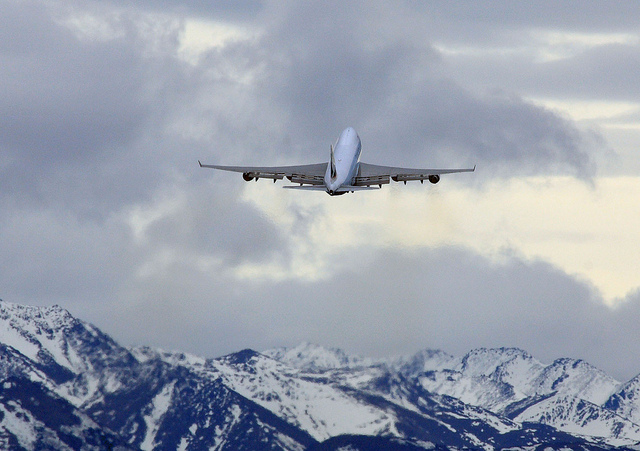What feelings does this image evoke? The image might evoke feelings of awe and freedom due to the vastness of the landscape and the airplane's flight, as well as a sense of wanderlust or a desire for adventure. 